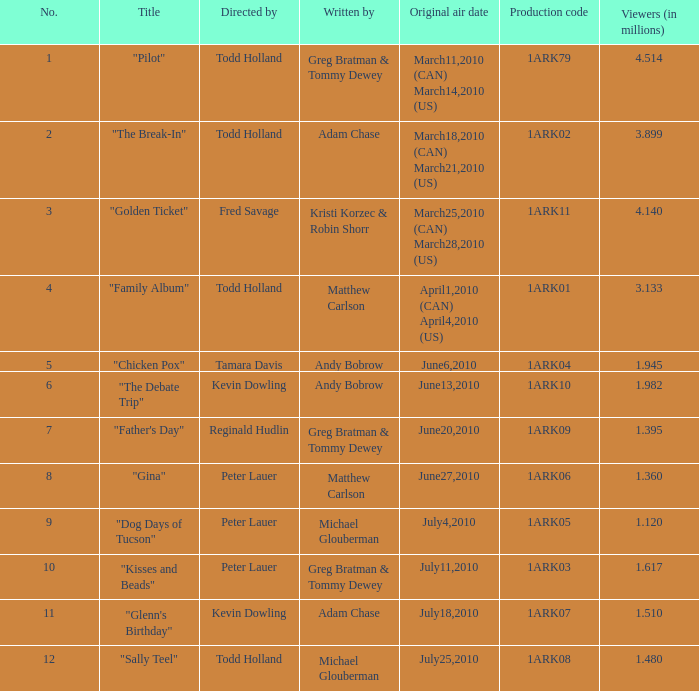List all directors from episodes with viewership of 1.945 million. Tamara Davis. 